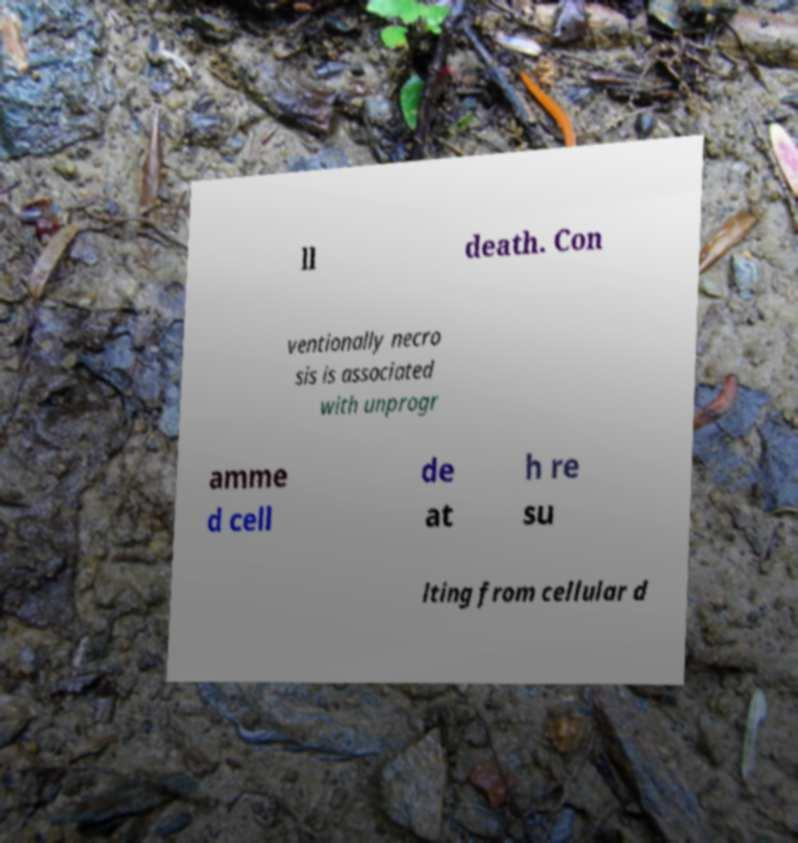I need the written content from this picture converted into text. Can you do that? ll death. Con ventionally necro sis is associated with unprogr amme d cell de at h re su lting from cellular d 